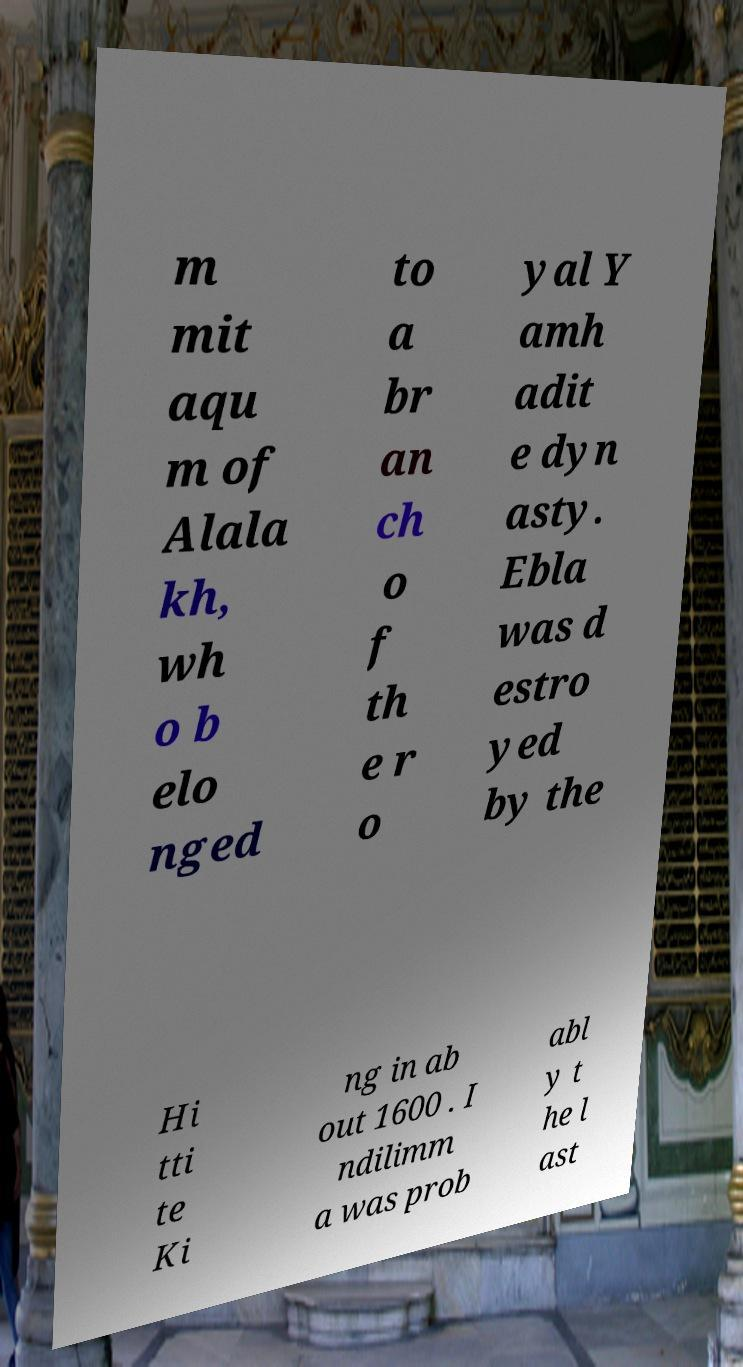What messages or text are displayed in this image? I need them in a readable, typed format. m mit aqu m of Alala kh, wh o b elo nged to a br an ch o f th e r o yal Y amh adit e dyn asty. Ebla was d estro yed by the Hi tti te Ki ng in ab out 1600 . I ndilimm a was prob abl y t he l ast 